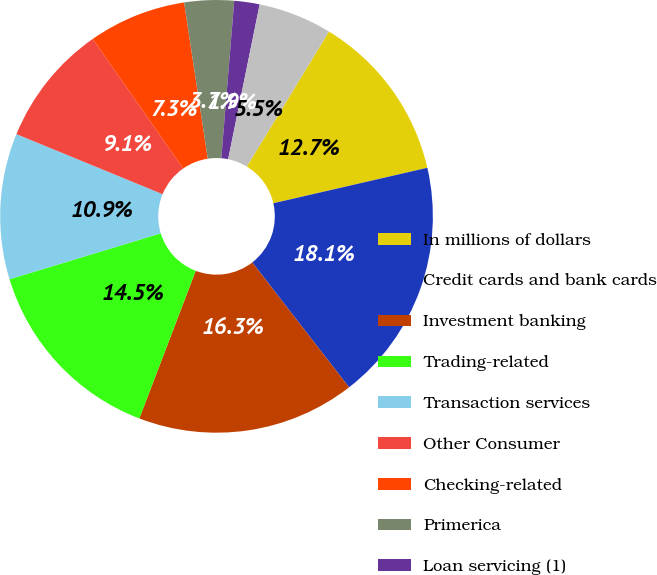Convert chart. <chart><loc_0><loc_0><loc_500><loc_500><pie_chart><fcel>In millions of dollars<fcel>Credit cards and bank cards<fcel>Investment banking<fcel>Trading-related<fcel>Transaction services<fcel>Other Consumer<fcel>Checking-related<fcel>Primerica<fcel>Loan servicing (1)<fcel>Corporate finance (2)<nl><fcel>12.7%<fcel>18.11%<fcel>16.3%<fcel>14.5%<fcel>10.9%<fcel>9.1%<fcel>7.3%<fcel>3.7%<fcel>1.89%<fcel>5.5%<nl></chart> 